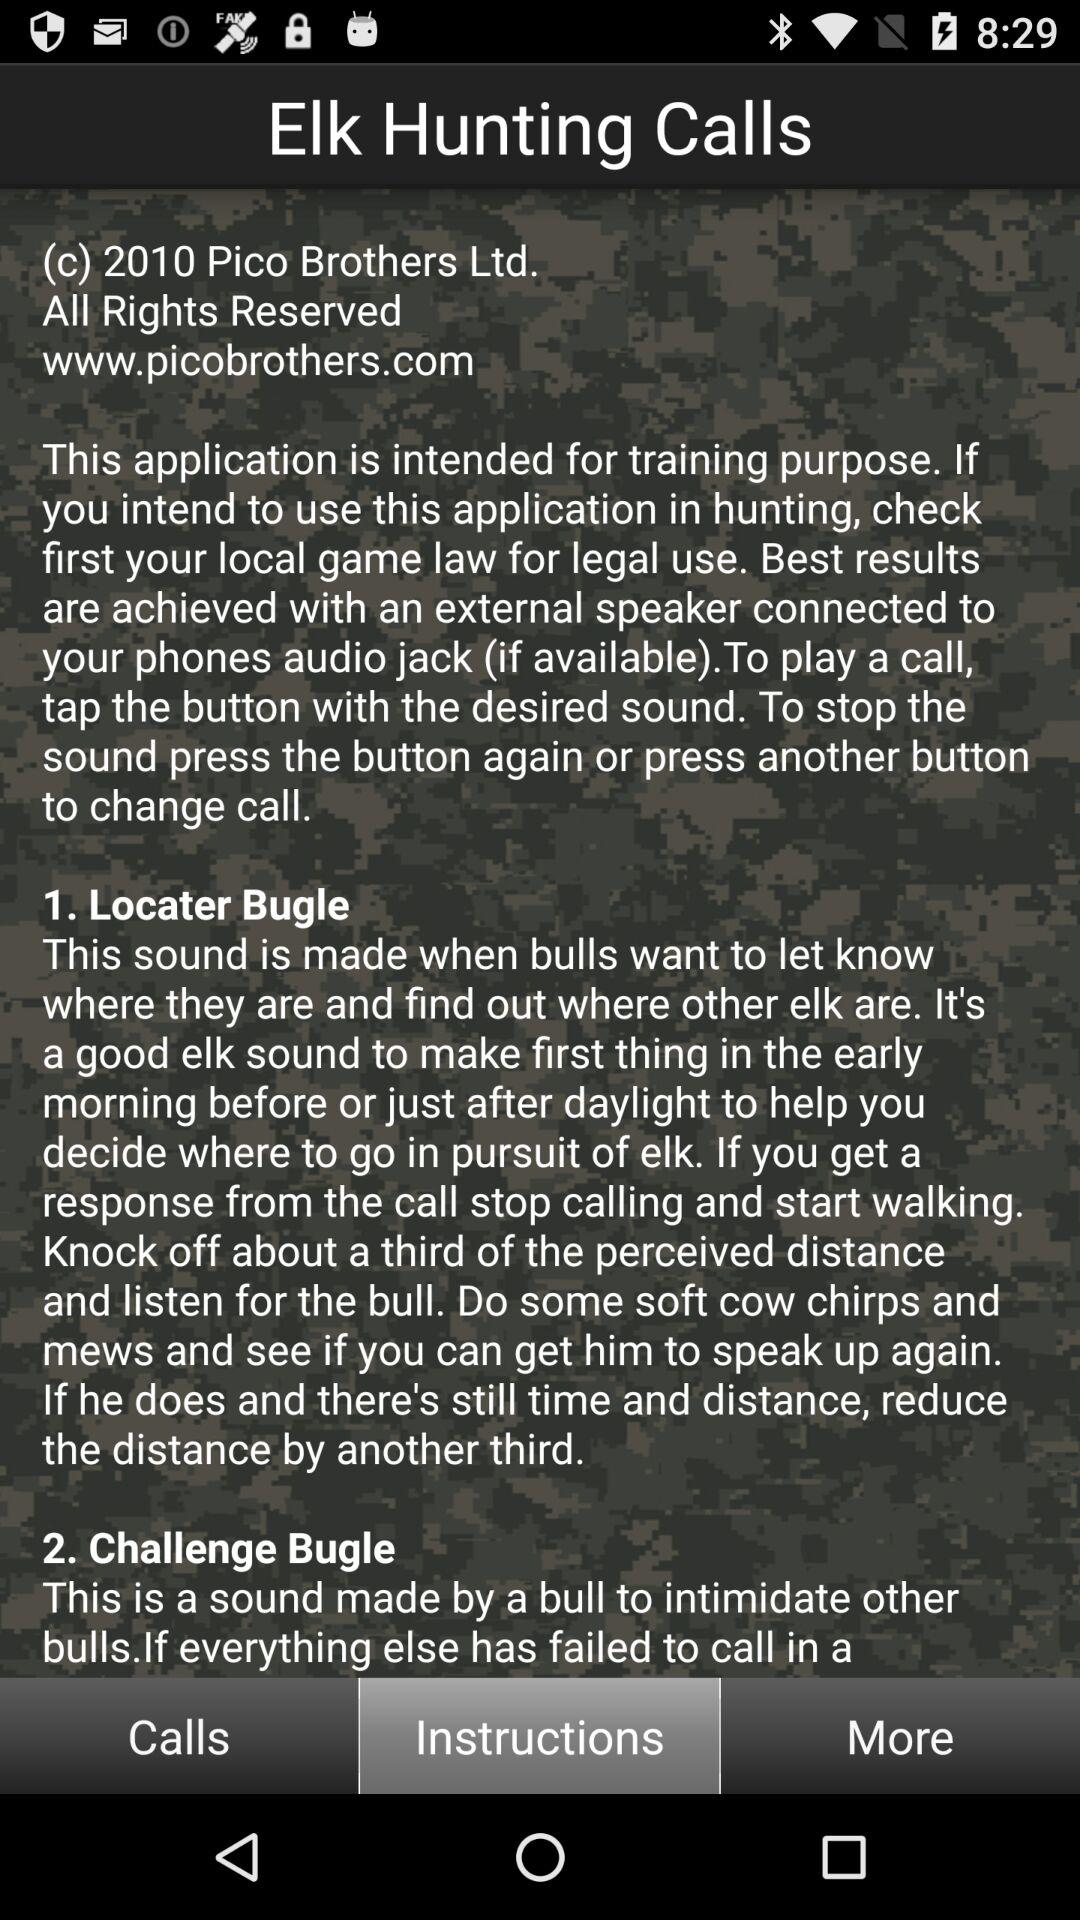How many calls are there in this app?
Answer the question using a single word or phrase. 2 